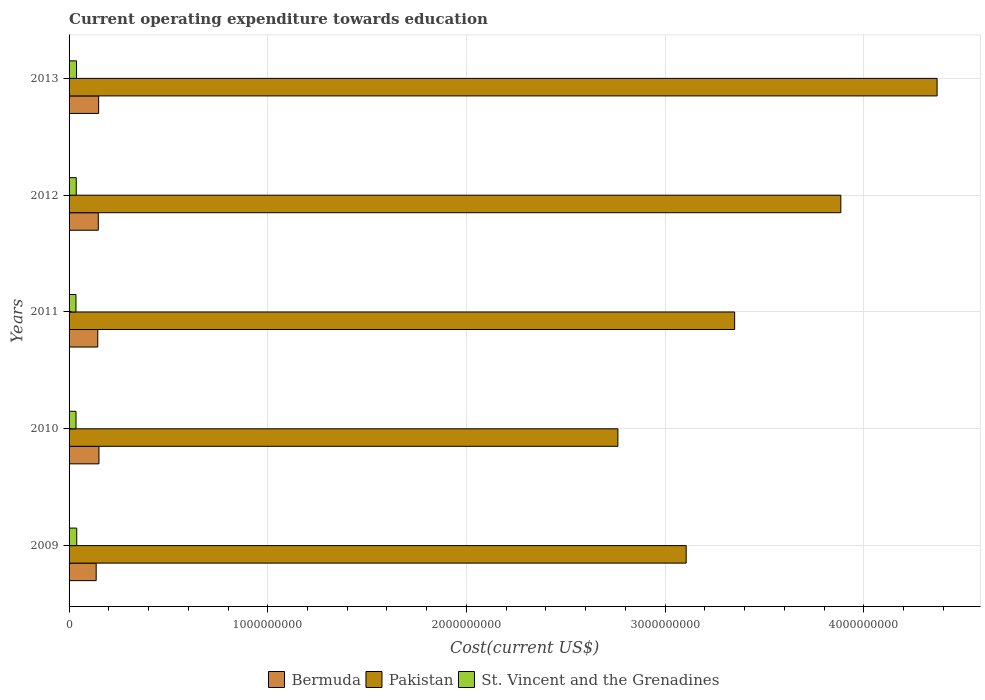How many different coloured bars are there?
Ensure brevity in your answer.  3. Are the number of bars on each tick of the Y-axis equal?
Offer a very short reply. Yes. How many bars are there on the 2nd tick from the top?
Make the answer very short. 3. What is the label of the 3rd group of bars from the top?
Ensure brevity in your answer.  2011. In how many cases, is the number of bars for a given year not equal to the number of legend labels?
Make the answer very short. 0. What is the expenditure towards education in Bermuda in 2013?
Keep it short and to the point. 1.49e+08. Across all years, what is the maximum expenditure towards education in Bermuda?
Your response must be concise. 1.50e+08. Across all years, what is the minimum expenditure towards education in St. Vincent and the Grenadines?
Offer a very short reply. 3.47e+07. In which year was the expenditure towards education in St. Vincent and the Grenadines maximum?
Your answer should be compact. 2009. What is the total expenditure towards education in Bermuda in the graph?
Offer a terse response. 7.27e+08. What is the difference between the expenditure towards education in Bermuda in 2010 and that in 2011?
Offer a terse response. 6.04e+06. What is the difference between the expenditure towards education in Bermuda in 2013 and the expenditure towards education in Pakistan in 2012?
Give a very brief answer. -3.74e+09. What is the average expenditure towards education in Bermuda per year?
Keep it short and to the point. 1.45e+08. In the year 2012, what is the difference between the expenditure towards education in Pakistan and expenditure towards education in Bermuda?
Make the answer very short. 3.74e+09. In how many years, is the expenditure towards education in Pakistan greater than 4000000000 US$?
Your answer should be compact. 1. What is the ratio of the expenditure towards education in Pakistan in 2009 to that in 2012?
Provide a succinct answer. 0.8. What is the difference between the highest and the second highest expenditure towards education in Pakistan?
Offer a very short reply. 4.84e+08. What is the difference between the highest and the lowest expenditure towards education in St. Vincent and the Grenadines?
Your response must be concise. 3.83e+06. In how many years, is the expenditure towards education in Bermuda greater than the average expenditure towards education in Bermuda taken over all years?
Your answer should be very brief. 3. Is the sum of the expenditure towards education in Pakistan in 2010 and 2011 greater than the maximum expenditure towards education in St. Vincent and the Grenadines across all years?
Offer a terse response. Yes. What does the 1st bar from the top in 2012 represents?
Provide a short and direct response. St. Vincent and the Grenadines. What does the 2nd bar from the bottom in 2009 represents?
Provide a short and direct response. Pakistan. Is it the case that in every year, the sum of the expenditure towards education in Bermuda and expenditure towards education in Pakistan is greater than the expenditure towards education in St. Vincent and the Grenadines?
Ensure brevity in your answer.  Yes. How many years are there in the graph?
Offer a very short reply. 5. What is the difference between two consecutive major ticks on the X-axis?
Provide a succinct answer. 1.00e+09. Are the values on the major ticks of X-axis written in scientific E-notation?
Ensure brevity in your answer.  No. Does the graph contain any zero values?
Make the answer very short. No. How many legend labels are there?
Ensure brevity in your answer.  3. How are the legend labels stacked?
Your response must be concise. Horizontal. What is the title of the graph?
Your response must be concise. Current operating expenditure towards education. What is the label or title of the X-axis?
Offer a very short reply. Cost(current US$). What is the Cost(current US$) of Bermuda in 2009?
Make the answer very short. 1.36e+08. What is the Cost(current US$) of Pakistan in 2009?
Your answer should be very brief. 3.11e+09. What is the Cost(current US$) in St. Vincent and the Grenadines in 2009?
Keep it short and to the point. 3.85e+07. What is the Cost(current US$) of Bermuda in 2010?
Your answer should be compact. 1.50e+08. What is the Cost(current US$) of Pakistan in 2010?
Offer a terse response. 2.76e+09. What is the Cost(current US$) of St. Vincent and the Grenadines in 2010?
Your response must be concise. 3.50e+07. What is the Cost(current US$) in Bermuda in 2011?
Your answer should be very brief. 1.44e+08. What is the Cost(current US$) of Pakistan in 2011?
Offer a very short reply. 3.35e+09. What is the Cost(current US$) in St. Vincent and the Grenadines in 2011?
Keep it short and to the point. 3.47e+07. What is the Cost(current US$) in Bermuda in 2012?
Keep it short and to the point. 1.47e+08. What is the Cost(current US$) of Pakistan in 2012?
Provide a short and direct response. 3.88e+09. What is the Cost(current US$) in St. Vincent and the Grenadines in 2012?
Your response must be concise. 3.61e+07. What is the Cost(current US$) of Bermuda in 2013?
Offer a terse response. 1.49e+08. What is the Cost(current US$) of Pakistan in 2013?
Give a very brief answer. 4.37e+09. What is the Cost(current US$) in St. Vincent and the Grenadines in 2013?
Offer a terse response. 3.76e+07. Across all years, what is the maximum Cost(current US$) of Bermuda?
Provide a short and direct response. 1.50e+08. Across all years, what is the maximum Cost(current US$) in Pakistan?
Provide a short and direct response. 4.37e+09. Across all years, what is the maximum Cost(current US$) in St. Vincent and the Grenadines?
Your response must be concise. 3.85e+07. Across all years, what is the minimum Cost(current US$) of Bermuda?
Provide a short and direct response. 1.36e+08. Across all years, what is the minimum Cost(current US$) in Pakistan?
Offer a very short reply. 2.76e+09. Across all years, what is the minimum Cost(current US$) in St. Vincent and the Grenadines?
Your answer should be compact. 3.47e+07. What is the total Cost(current US$) in Bermuda in the graph?
Your answer should be compact. 7.27e+08. What is the total Cost(current US$) in Pakistan in the graph?
Offer a very short reply. 1.75e+1. What is the total Cost(current US$) in St. Vincent and the Grenadines in the graph?
Provide a short and direct response. 1.82e+08. What is the difference between the Cost(current US$) in Bermuda in 2009 and that in 2010?
Provide a short and direct response. -1.39e+07. What is the difference between the Cost(current US$) of Pakistan in 2009 and that in 2010?
Your response must be concise. 3.44e+08. What is the difference between the Cost(current US$) in St. Vincent and the Grenadines in 2009 and that in 2010?
Your response must be concise. 3.57e+06. What is the difference between the Cost(current US$) in Bermuda in 2009 and that in 2011?
Offer a very short reply. -7.90e+06. What is the difference between the Cost(current US$) in Pakistan in 2009 and that in 2011?
Your response must be concise. -2.44e+08. What is the difference between the Cost(current US$) of St. Vincent and the Grenadines in 2009 and that in 2011?
Offer a very short reply. 3.83e+06. What is the difference between the Cost(current US$) of Bermuda in 2009 and that in 2012?
Offer a very short reply. -1.05e+07. What is the difference between the Cost(current US$) in Pakistan in 2009 and that in 2012?
Make the answer very short. -7.79e+08. What is the difference between the Cost(current US$) in St. Vincent and the Grenadines in 2009 and that in 2012?
Your answer should be very brief. 2.44e+06. What is the difference between the Cost(current US$) of Bermuda in 2009 and that in 2013?
Your answer should be very brief. -1.23e+07. What is the difference between the Cost(current US$) in Pakistan in 2009 and that in 2013?
Make the answer very short. -1.26e+09. What is the difference between the Cost(current US$) in St. Vincent and the Grenadines in 2009 and that in 2013?
Ensure brevity in your answer.  9.59e+05. What is the difference between the Cost(current US$) of Bermuda in 2010 and that in 2011?
Give a very brief answer. 6.04e+06. What is the difference between the Cost(current US$) in Pakistan in 2010 and that in 2011?
Give a very brief answer. -5.88e+08. What is the difference between the Cost(current US$) of St. Vincent and the Grenadines in 2010 and that in 2011?
Provide a succinct answer. 2.61e+05. What is the difference between the Cost(current US$) in Bermuda in 2010 and that in 2012?
Your response must be concise. 3.40e+06. What is the difference between the Cost(current US$) of Pakistan in 2010 and that in 2012?
Make the answer very short. -1.12e+09. What is the difference between the Cost(current US$) of St. Vincent and the Grenadines in 2010 and that in 2012?
Your response must be concise. -1.13e+06. What is the difference between the Cost(current US$) in Bermuda in 2010 and that in 2013?
Make the answer very short. 1.62e+06. What is the difference between the Cost(current US$) of Pakistan in 2010 and that in 2013?
Your answer should be compact. -1.61e+09. What is the difference between the Cost(current US$) in St. Vincent and the Grenadines in 2010 and that in 2013?
Offer a very short reply. -2.61e+06. What is the difference between the Cost(current US$) in Bermuda in 2011 and that in 2012?
Offer a very short reply. -2.64e+06. What is the difference between the Cost(current US$) in Pakistan in 2011 and that in 2012?
Provide a short and direct response. -5.34e+08. What is the difference between the Cost(current US$) of St. Vincent and the Grenadines in 2011 and that in 2012?
Give a very brief answer. -1.39e+06. What is the difference between the Cost(current US$) of Bermuda in 2011 and that in 2013?
Provide a short and direct response. -4.42e+06. What is the difference between the Cost(current US$) of Pakistan in 2011 and that in 2013?
Ensure brevity in your answer.  -1.02e+09. What is the difference between the Cost(current US$) in St. Vincent and the Grenadines in 2011 and that in 2013?
Keep it short and to the point. -2.87e+06. What is the difference between the Cost(current US$) of Bermuda in 2012 and that in 2013?
Offer a terse response. -1.78e+06. What is the difference between the Cost(current US$) of Pakistan in 2012 and that in 2013?
Your answer should be very brief. -4.84e+08. What is the difference between the Cost(current US$) of St. Vincent and the Grenadines in 2012 and that in 2013?
Your answer should be very brief. -1.48e+06. What is the difference between the Cost(current US$) of Bermuda in 2009 and the Cost(current US$) of Pakistan in 2010?
Your answer should be compact. -2.63e+09. What is the difference between the Cost(current US$) in Bermuda in 2009 and the Cost(current US$) in St. Vincent and the Grenadines in 2010?
Your response must be concise. 1.02e+08. What is the difference between the Cost(current US$) of Pakistan in 2009 and the Cost(current US$) of St. Vincent and the Grenadines in 2010?
Offer a terse response. 3.07e+09. What is the difference between the Cost(current US$) of Bermuda in 2009 and the Cost(current US$) of Pakistan in 2011?
Provide a succinct answer. -3.21e+09. What is the difference between the Cost(current US$) in Bermuda in 2009 and the Cost(current US$) in St. Vincent and the Grenadines in 2011?
Provide a succinct answer. 1.02e+08. What is the difference between the Cost(current US$) of Pakistan in 2009 and the Cost(current US$) of St. Vincent and the Grenadines in 2011?
Your response must be concise. 3.07e+09. What is the difference between the Cost(current US$) of Bermuda in 2009 and the Cost(current US$) of Pakistan in 2012?
Ensure brevity in your answer.  -3.75e+09. What is the difference between the Cost(current US$) in Bermuda in 2009 and the Cost(current US$) in St. Vincent and the Grenadines in 2012?
Provide a succinct answer. 1.00e+08. What is the difference between the Cost(current US$) in Pakistan in 2009 and the Cost(current US$) in St. Vincent and the Grenadines in 2012?
Provide a short and direct response. 3.07e+09. What is the difference between the Cost(current US$) in Bermuda in 2009 and the Cost(current US$) in Pakistan in 2013?
Your answer should be compact. -4.23e+09. What is the difference between the Cost(current US$) in Bermuda in 2009 and the Cost(current US$) in St. Vincent and the Grenadines in 2013?
Make the answer very short. 9.89e+07. What is the difference between the Cost(current US$) in Pakistan in 2009 and the Cost(current US$) in St. Vincent and the Grenadines in 2013?
Your response must be concise. 3.07e+09. What is the difference between the Cost(current US$) of Bermuda in 2010 and the Cost(current US$) of Pakistan in 2011?
Offer a very short reply. -3.20e+09. What is the difference between the Cost(current US$) in Bermuda in 2010 and the Cost(current US$) in St. Vincent and the Grenadines in 2011?
Offer a very short reply. 1.16e+08. What is the difference between the Cost(current US$) in Pakistan in 2010 and the Cost(current US$) in St. Vincent and the Grenadines in 2011?
Make the answer very short. 2.73e+09. What is the difference between the Cost(current US$) of Bermuda in 2010 and the Cost(current US$) of Pakistan in 2012?
Make the answer very short. -3.73e+09. What is the difference between the Cost(current US$) of Bermuda in 2010 and the Cost(current US$) of St. Vincent and the Grenadines in 2012?
Give a very brief answer. 1.14e+08. What is the difference between the Cost(current US$) in Pakistan in 2010 and the Cost(current US$) in St. Vincent and the Grenadines in 2012?
Keep it short and to the point. 2.73e+09. What is the difference between the Cost(current US$) in Bermuda in 2010 and the Cost(current US$) in Pakistan in 2013?
Provide a short and direct response. -4.22e+09. What is the difference between the Cost(current US$) in Bermuda in 2010 and the Cost(current US$) in St. Vincent and the Grenadines in 2013?
Offer a very short reply. 1.13e+08. What is the difference between the Cost(current US$) of Pakistan in 2010 and the Cost(current US$) of St. Vincent and the Grenadines in 2013?
Your response must be concise. 2.72e+09. What is the difference between the Cost(current US$) of Bermuda in 2011 and the Cost(current US$) of Pakistan in 2012?
Your answer should be very brief. -3.74e+09. What is the difference between the Cost(current US$) in Bermuda in 2011 and the Cost(current US$) in St. Vincent and the Grenadines in 2012?
Provide a succinct answer. 1.08e+08. What is the difference between the Cost(current US$) of Pakistan in 2011 and the Cost(current US$) of St. Vincent and the Grenadines in 2012?
Your answer should be compact. 3.31e+09. What is the difference between the Cost(current US$) in Bermuda in 2011 and the Cost(current US$) in Pakistan in 2013?
Ensure brevity in your answer.  -4.22e+09. What is the difference between the Cost(current US$) of Bermuda in 2011 and the Cost(current US$) of St. Vincent and the Grenadines in 2013?
Offer a terse response. 1.07e+08. What is the difference between the Cost(current US$) in Pakistan in 2011 and the Cost(current US$) in St. Vincent and the Grenadines in 2013?
Give a very brief answer. 3.31e+09. What is the difference between the Cost(current US$) of Bermuda in 2012 and the Cost(current US$) of Pakistan in 2013?
Give a very brief answer. -4.22e+09. What is the difference between the Cost(current US$) in Bermuda in 2012 and the Cost(current US$) in St. Vincent and the Grenadines in 2013?
Provide a short and direct response. 1.09e+08. What is the difference between the Cost(current US$) in Pakistan in 2012 and the Cost(current US$) in St. Vincent and the Grenadines in 2013?
Provide a succinct answer. 3.85e+09. What is the average Cost(current US$) of Bermuda per year?
Make the answer very short. 1.45e+08. What is the average Cost(current US$) of Pakistan per year?
Ensure brevity in your answer.  3.49e+09. What is the average Cost(current US$) in St. Vincent and the Grenadines per year?
Keep it short and to the point. 3.64e+07. In the year 2009, what is the difference between the Cost(current US$) of Bermuda and Cost(current US$) of Pakistan?
Provide a succinct answer. -2.97e+09. In the year 2009, what is the difference between the Cost(current US$) of Bermuda and Cost(current US$) of St. Vincent and the Grenadines?
Provide a short and direct response. 9.79e+07. In the year 2009, what is the difference between the Cost(current US$) of Pakistan and Cost(current US$) of St. Vincent and the Grenadines?
Ensure brevity in your answer.  3.07e+09. In the year 2010, what is the difference between the Cost(current US$) of Bermuda and Cost(current US$) of Pakistan?
Keep it short and to the point. -2.61e+09. In the year 2010, what is the difference between the Cost(current US$) in Bermuda and Cost(current US$) in St. Vincent and the Grenadines?
Offer a very short reply. 1.15e+08. In the year 2010, what is the difference between the Cost(current US$) of Pakistan and Cost(current US$) of St. Vincent and the Grenadines?
Provide a succinct answer. 2.73e+09. In the year 2011, what is the difference between the Cost(current US$) of Bermuda and Cost(current US$) of Pakistan?
Your answer should be very brief. -3.21e+09. In the year 2011, what is the difference between the Cost(current US$) in Bermuda and Cost(current US$) in St. Vincent and the Grenadines?
Make the answer very short. 1.10e+08. In the year 2011, what is the difference between the Cost(current US$) in Pakistan and Cost(current US$) in St. Vincent and the Grenadines?
Make the answer very short. 3.32e+09. In the year 2012, what is the difference between the Cost(current US$) of Bermuda and Cost(current US$) of Pakistan?
Provide a succinct answer. -3.74e+09. In the year 2012, what is the difference between the Cost(current US$) of Bermuda and Cost(current US$) of St. Vincent and the Grenadines?
Provide a succinct answer. 1.11e+08. In the year 2012, what is the difference between the Cost(current US$) in Pakistan and Cost(current US$) in St. Vincent and the Grenadines?
Offer a very short reply. 3.85e+09. In the year 2013, what is the difference between the Cost(current US$) of Bermuda and Cost(current US$) of Pakistan?
Make the answer very short. -4.22e+09. In the year 2013, what is the difference between the Cost(current US$) of Bermuda and Cost(current US$) of St. Vincent and the Grenadines?
Your response must be concise. 1.11e+08. In the year 2013, what is the difference between the Cost(current US$) of Pakistan and Cost(current US$) of St. Vincent and the Grenadines?
Your answer should be compact. 4.33e+09. What is the ratio of the Cost(current US$) in Bermuda in 2009 to that in 2010?
Provide a succinct answer. 0.91. What is the ratio of the Cost(current US$) in Pakistan in 2009 to that in 2010?
Ensure brevity in your answer.  1.12. What is the ratio of the Cost(current US$) in St. Vincent and the Grenadines in 2009 to that in 2010?
Offer a very short reply. 1.1. What is the ratio of the Cost(current US$) in Bermuda in 2009 to that in 2011?
Your response must be concise. 0.95. What is the ratio of the Cost(current US$) of Pakistan in 2009 to that in 2011?
Provide a succinct answer. 0.93. What is the ratio of the Cost(current US$) of St. Vincent and the Grenadines in 2009 to that in 2011?
Provide a succinct answer. 1.11. What is the ratio of the Cost(current US$) of Bermuda in 2009 to that in 2012?
Offer a terse response. 0.93. What is the ratio of the Cost(current US$) in Pakistan in 2009 to that in 2012?
Your answer should be very brief. 0.8. What is the ratio of the Cost(current US$) in St. Vincent and the Grenadines in 2009 to that in 2012?
Offer a terse response. 1.07. What is the ratio of the Cost(current US$) in Bermuda in 2009 to that in 2013?
Ensure brevity in your answer.  0.92. What is the ratio of the Cost(current US$) of Pakistan in 2009 to that in 2013?
Keep it short and to the point. 0.71. What is the ratio of the Cost(current US$) of St. Vincent and the Grenadines in 2009 to that in 2013?
Provide a short and direct response. 1.03. What is the ratio of the Cost(current US$) of Bermuda in 2010 to that in 2011?
Provide a short and direct response. 1.04. What is the ratio of the Cost(current US$) in Pakistan in 2010 to that in 2011?
Offer a terse response. 0.82. What is the ratio of the Cost(current US$) in St. Vincent and the Grenadines in 2010 to that in 2011?
Provide a short and direct response. 1.01. What is the ratio of the Cost(current US$) in Bermuda in 2010 to that in 2012?
Offer a very short reply. 1.02. What is the ratio of the Cost(current US$) in Pakistan in 2010 to that in 2012?
Provide a succinct answer. 0.71. What is the ratio of the Cost(current US$) of St. Vincent and the Grenadines in 2010 to that in 2012?
Make the answer very short. 0.97. What is the ratio of the Cost(current US$) of Bermuda in 2010 to that in 2013?
Offer a very short reply. 1.01. What is the ratio of the Cost(current US$) in Pakistan in 2010 to that in 2013?
Give a very brief answer. 0.63. What is the ratio of the Cost(current US$) of St. Vincent and the Grenadines in 2010 to that in 2013?
Offer a very short reply. 0.93. What is the ratio of the Cost(current US$) of Bermuda in 2011 to that in 2012?
Keep it short and to the point. 0.98. What is the ratio of the Cost(current US$) of Pakistan in 2011 to that in 2012?
Your response must be concise. 0.86. What is the ratio of the Cost(current US$) in St. Vincent and the Grenadines in 2011 to that in 2012?
Ensure brevity in your answer.  0.96. What is the ratio of the Cost(current US$) of Bermuda in 2011 to that in 2013?
Offer a very short reply. 0.97. What is the ratio of the Cost(current US$) in Pakistan in 2011 to that in 2013?
Keep it short and to the point. 0.77. What is the ratio of the Cost(current US$) of St. Vincent and the Grenadines in 2011 to that in 2013?
Provide a succinct answer. 0.92. What is the ratio of the Cost(current US$) of Bermuda in 2012 to that in 2013?
Your response must be concise. 0.99. What is the ratio of the Cost(current US$) in Pakistan in 2012 to that in 2013?
Give a very brief answer. 0.89. What is the ratio of the Cost(current US$) in St. Vincent and the Grenadines in 2012 to that in 2013?
Offer a terse response. 0.96. What is the difference between the highest and the second highest Cost(current US$) of Bermuda?
Provide a succinct answer. 1.62e+06. What is the difference between the highest and the second highest Cost(current US$) of Pakistan?
Provide a short and direct response. 4.84e+08. What is the difference between the highest and the second highest Cost(current US$) of St. Vincent and the Grenadines?
Offer a terse response. 9.59e+05. What is the difference between the highest and the lowest Cost(current US$) in Bermuda?
Your response must be concise. 1.39e+07. What is the difference between the highest and the lowest Cost(current US$) in Pakistan?
Your answer should be compact. 1.61e+09. What is the difference between the highest and the lowest Cost(current US$) in St. Vincent and the Grenadines?
Provide a succinct answer. 3.83e+06. 